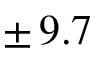<formula> <loc_0><loc_0><loc_500><loc_500>\pm \, 9 . 7</formula> 